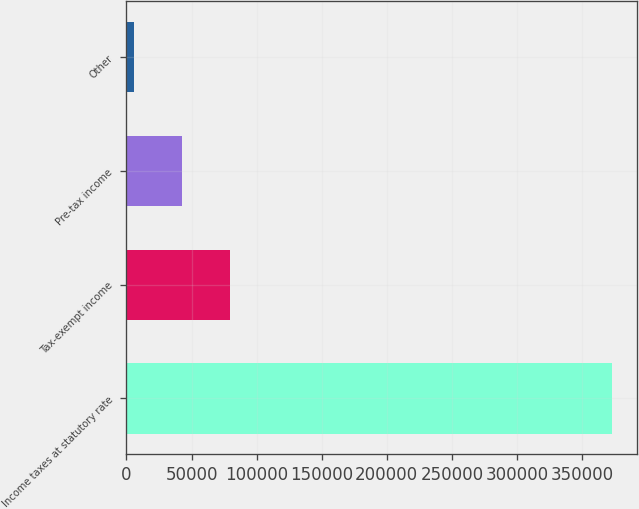Convert chart. <chart><loc_0><loc_0><loc_500><loc_500><bar_chart><fcel>Income taxes at statutory rate<fcel>Tax-exempt income<fcel>Pre-tax income<fcel>Other<nl><fcel>373283<fcel>79321.4<fcel>42576.2<fcel>5831<nl></chart> 